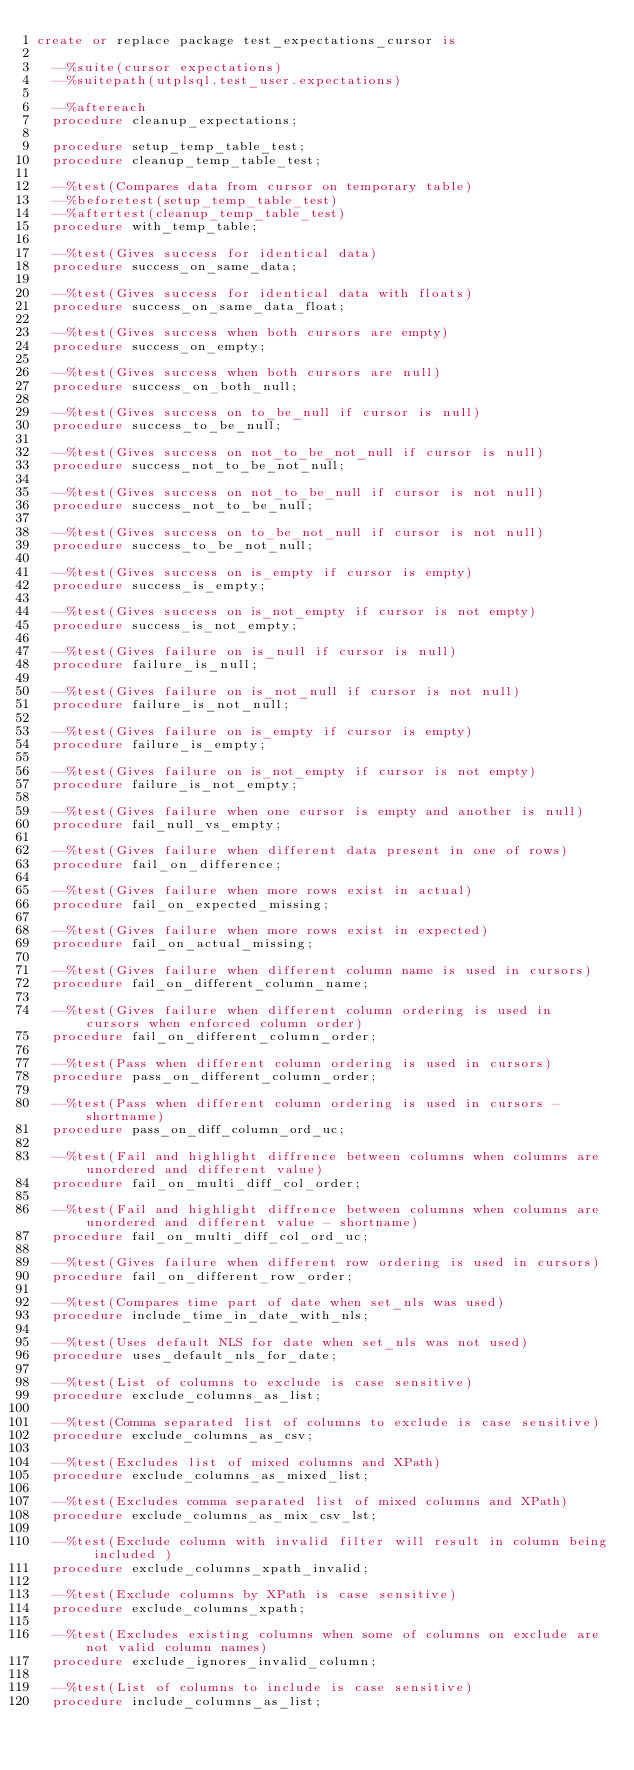<code> <loc_0><loc_0><loc_500><loc_500><_SQL_>create or replace package test_expectations_cursor is

  --%suite(cursor expectations)
  --%suitepath(utplsql.test_user.expectations)

  --%aftereach
  procedure cleanup_expectations;

  procedure setup_temp_table_test;
  procedure cleanup_temp_table_test;

  --%test(Compares data from cursor on temporary table)
  --%beforetest(setup_temp_table_test)
  --%aftertest(cleanup_temp_table_test)
  procedure with_temp_table;

  --%test(Gives success for identical data)
  procedure success_on_same_data;

  --%test(Gives success for identical data with floats)
  procedure success_on_same_data_float;

  --%test(Gives success when both cursors are empty)
  procedure success_on_empty;

  --%test(Gives success when both cursors are null)
  procedure success_on_both_null;

  --%test(Gives success on to_be_null if cursor is null)
  procedure success_to_be_null;

  --%test(Gives success on not_to_be_not_null if cursor is null)
  procedure success_not_to_be_not_null;

  --%test(Gives success on not_to_be_null if cursor is not null)
  procedure success_not_to_be_null;

  --%test(Gives success on to_be_not_null if cursor is not null)
  procedure success_to_be_not_null;

  --%test(Gives success on is_empty if cursor is empty)
  procedure success_is_empty;

  --%test(Gives success on is_not_empty if cursor is not empty)
  procedure success_is_not_empty;

  --%test(Gives failure on is_null if cursor is null)
  procedure failure_is_null;

  --%test(Gives failure on is_not_null if cursor is not null)
  procedure failure_is_not_null;

  --%test(Gives failure on is_empty if cursor is empty)
  procedure failure_is_empty;

  --%test(Gives failure on is_not_empty if cursor is not empty)
  procedure failure_is_not_empty;

  --%test(Gives failure when one cursor is empty and another is null)
  procedure fail_null_vs_empty;

  --%test(Gives failure when different data present in one of rows)
  procedure fail_on_difference;

  --%test(Gives failure when more rows exist in actual)
  procedure fail_on_expected_missing;

  --%test(Gives failure when more rows exist in expected)
  procedure fail_on_actual_missing;

  --%test(Gives failure when different column name is used in cursors)
  procedure fail_on_different_column_name;

  --%test(Gives failure when different column ordering is used in cursors when enforced column order)
  procedure fail_on_different_column_order;

  --%test(Pass when different column ordering is used in cursors)
  procedure pass_on_different_column_order;

  --%test(Pass when different column ordering is used in cursors - shortname)
  procedure pass_on_diff_column_ord_uc;

  --%test(Fail and highlight diffrence between columns when columns are unordered and different value)
  procedure fail_on_multi_diff_col_order;

  --%test(Fail and highlight diffrence between columns when columns are unordered and different value - shortname)
  procedure fail_on_multi_diff_col_ord_uc;

  --%test(Gives failure when different row ordering is used in cursors)
  procedure fail_on_different_row_order;

  --%test(Compares time part of date when set_nls was used)
  procedure include_time_in_date_with_nls;

  --%test(Uses default NLS for date when set_nls was not used)
  procedure uses_default_nls_for_date;

  --%test(List of columns to exclude is case sensitive)
  procedure exclude_columns_as_list;

  --%test(Comma separated list of columns to exclude is case sensitive)
  procedure exclude_columns_as_csv;

  --%test(Excludes list of mixed columns and XPath)
  procedure exclude_columns_as_mixed_list;

  --%test(Excludes comma separated list of mixed columns and XPath)
  procedure exclude_columns_as_mix_csv_lst;

  --%test(Exclude column with invalid filter will result in column being included )
  procedure exclude_columns_xpath_invalid;

  --%test(Exclude columns by XPath is case sensitive)
  procedure exclude_columns_xpath;

  --%test(Excludes existing columns when some of columns on exclude are not valid column names)
  procedure exclude_ignores_invalid_column;

  --%test(List of columns to include is case sensitive)
  procedure include_columns_as_list;
</code> 